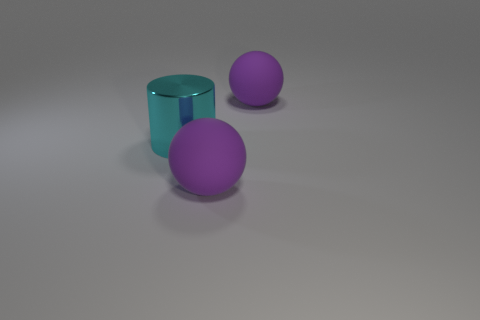Is the material of the cylinder the same as the object that is behind the big metal object?
Provide a short and direct response. No. There is a purple matte thing that is to the right of the matte ball in front of the cyan cylinder; what shape is it?
Your answer should be compact. Sphere. Is the size of the purple rubber thing that is behind the cyan object the same as the cyan thing?
Offer a very short reply. Yes. How many other objects are the same shape as the big metal object?
Provide a succinct answer. 0. There is a thing in front of the metallic cylinder; is it the same color as the large cylinder?
Keep it short and to the point. No. Is there another large matte cylinder of the same color as the big cylinder?
Make the answer very short. No. There is a big metal thing; how many big purple matte spheres are on the right side of it?
Your answer should be compact. 2. What number of other things are the same size as the cyan shiny object?
Your answer should be compact. 2. Is the material of the purple object in front of the cyan metallic cylinder the same as the large purple object behind the large cyan cylinder?
Make the answer very short. Yes. Is there any other thing of the same color as the cylinder?
Ensure brevity in your answer.  No. 